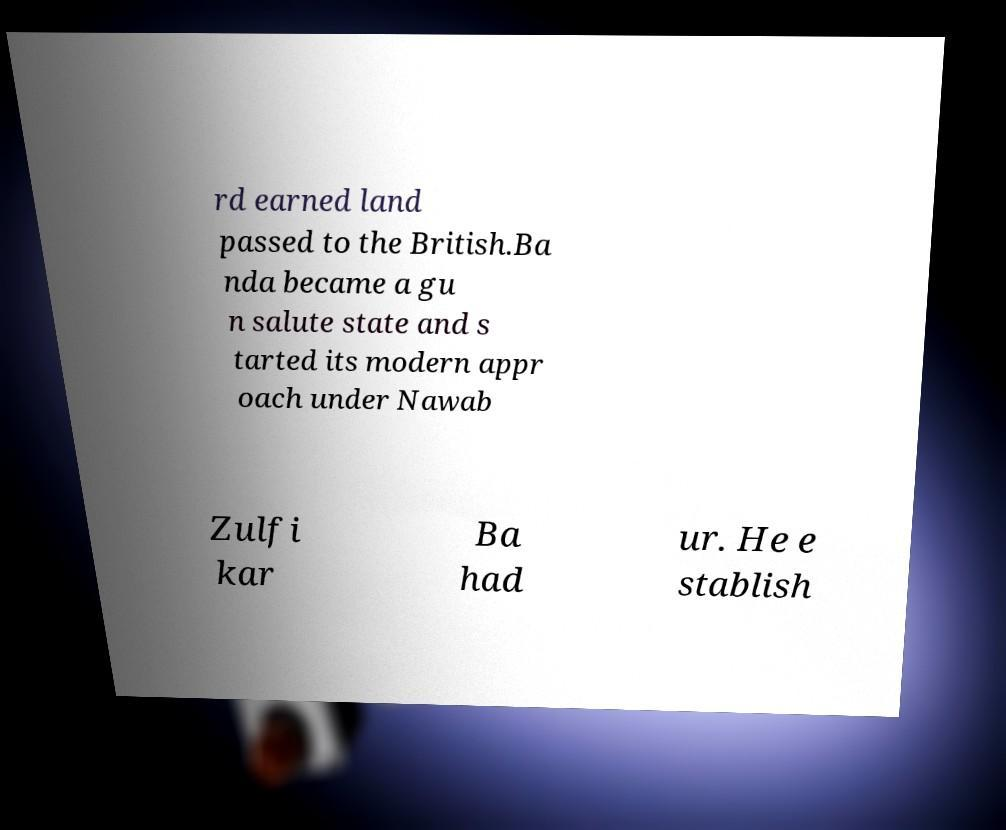Can you accurately transcribe the text from the provided image for me? rd earned land passed to the British.Ba nda became a gu n salute state and s tarted its modern appr oach under Nawab Zulfi kar Ba had ur. He e stablish 